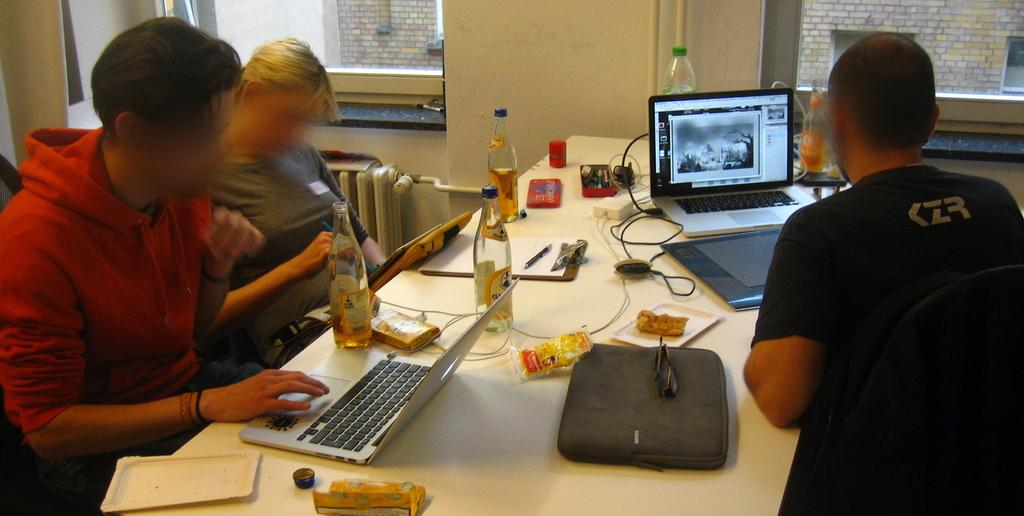<image>
Give a short and clear explanation of the subsequent image. people at  a shared desk and one worker's shirt reads KZR 